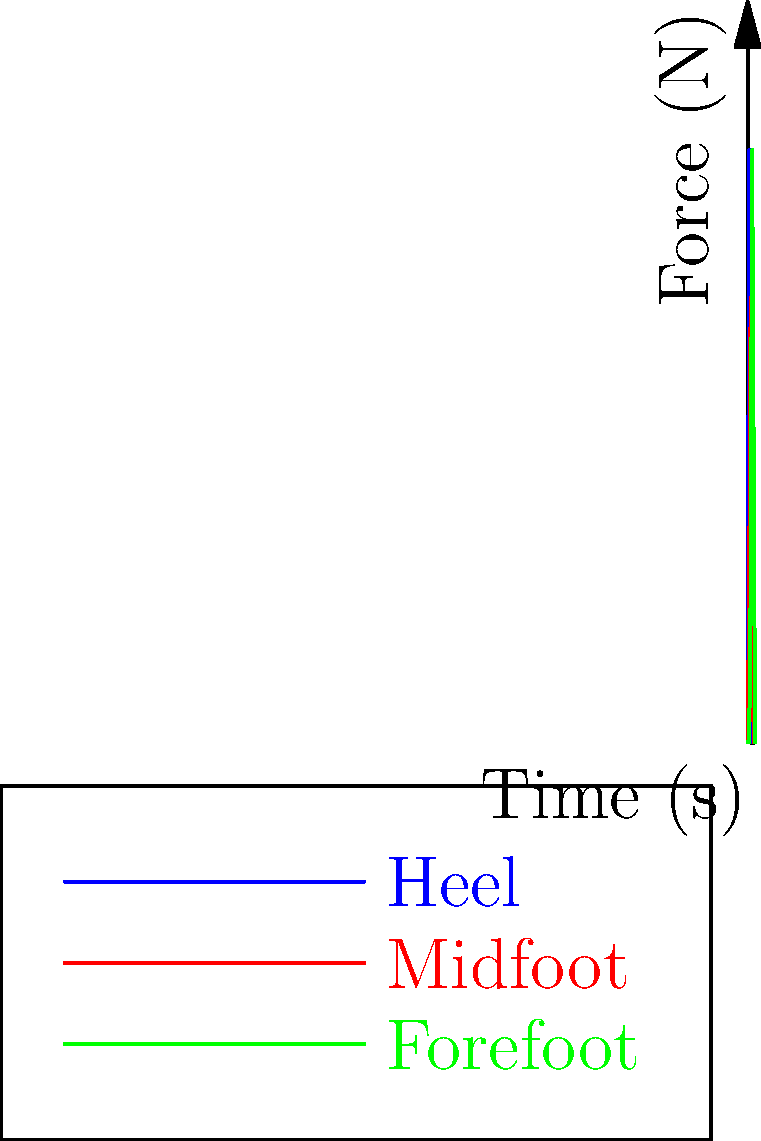Analyze the force distribution graph for a humanoid robot's foot during a single step cycle. Which part of the foot experiences the highest peak force, and at approximately what time during the step does this occur? To answer this question, we need to examine the force distribution graph for the humanoid robot's foot during a single step cycle. The graph shows the force applied to three different parts of the foot (heel, midfoot, and forefoot) over time. Let's break down the analysis:

1. Heel (blue line):
   - Peak force: Approximately 400 N
   - Time of peak: Around 1 second

2. Midfoot (red line):
   - Peak force: Approximately 300 N
   - Time of peak: Around 2 seconds

3. Forefoot (green line):
   - Peak force: Approximately 400 N
   - Time of peak: Around 3 seconds

Comparing the peak forces:
- Heel: 400 N
- Midfoot: 300 N
- Forefoot: 400 N

We can see that both the heel and forefoot experience the highest peak force of about 400 N. However, the question asks for a single answer, so we need to determine which occurs first.

The heel experiences its peak force at around 1 second, while the forefoot experiences its peak force at around 3 seconds.

Therefore, the part of the foot that experiences the highest peak force first is the heel, occurring at approximately 1 second into the step cycle.
Answer: Heel, at approximately 1 second 